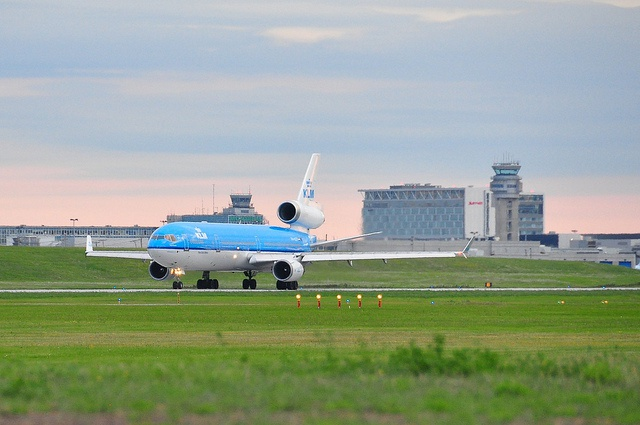Describe the objects in this image and their specific colors. I can see a airplane in lightgray, darkgray, lightblue, and black tones in this image. 